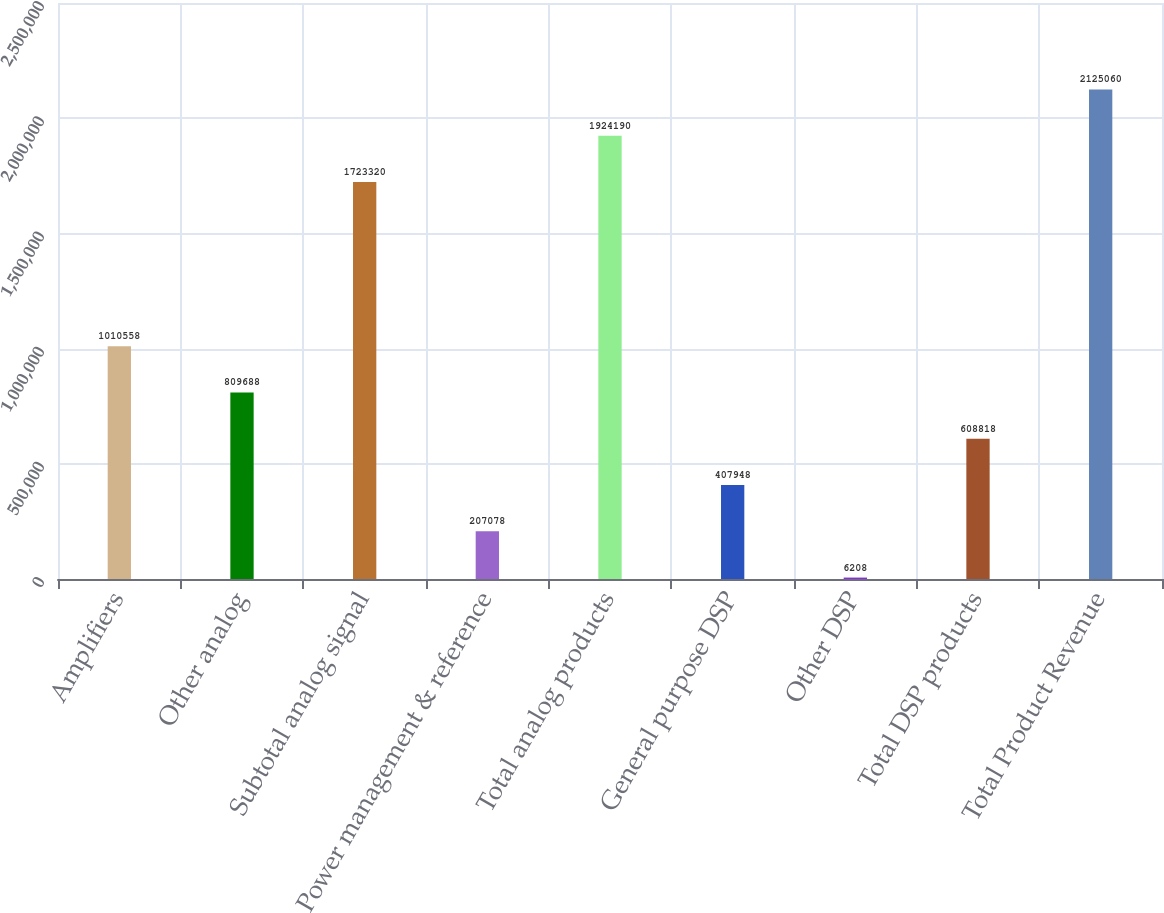Convert chart to OTSL. <chart><loc_0><loc_0><loc_500><loc_500><bar_chart><fcel>Amplifiers<fcel>Other analog<fcel>Subtotal analog signal<fcel>Power management & reference<fcel>Total analog products<fcel>General purpose DSP<fcel>Other DSP<fcel>Total DSP products<fcel>Total Product Revenue<nl><fcel>1.01056e+06<fcel>809688<fcel>1.72332e+06<fcel>207078<fcel>1.92419e+06<fcel>407948<fcel>6208<fcel>608818<fcel>2.12506e+06<nl></chart> 